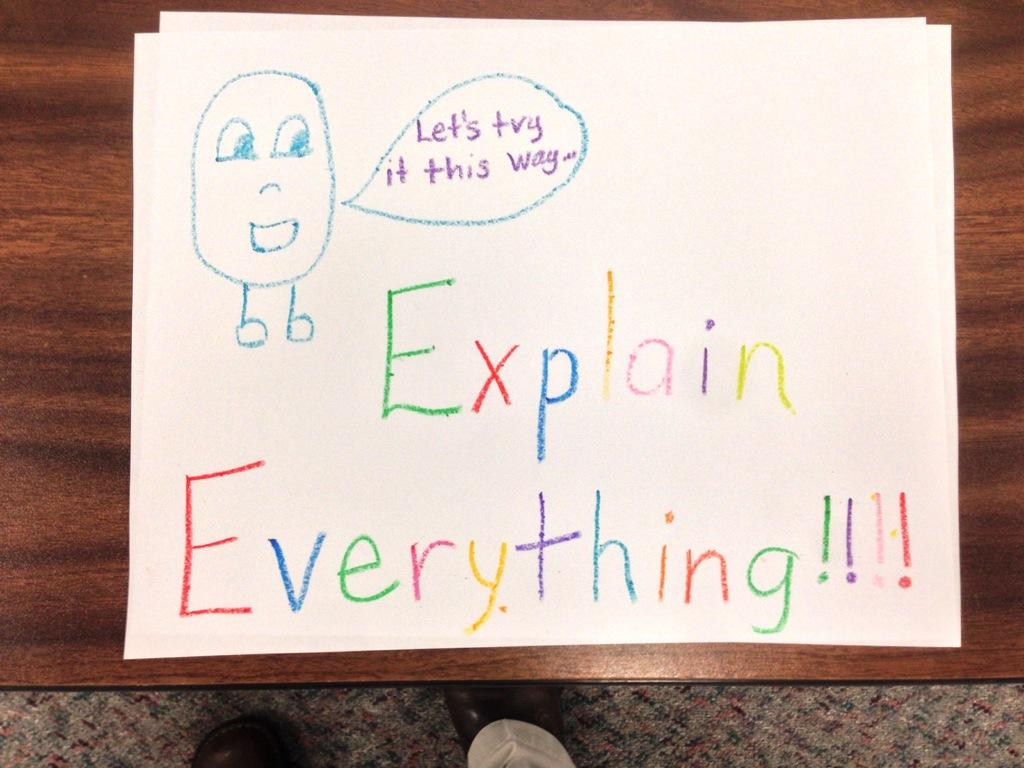<image>
Create a compact narrative representing the image presented. a white paper with colored letters that say 'explain everything' 